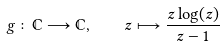Convert formula to latex. <formula><loc_0><loc_0><loc_500><loc_500>g \colon \mathbb { C } \longrightarrow \mathbb { C } , \quad z \longmapsto \frac { z \log ( z ) } { z - 1 }</formula> 